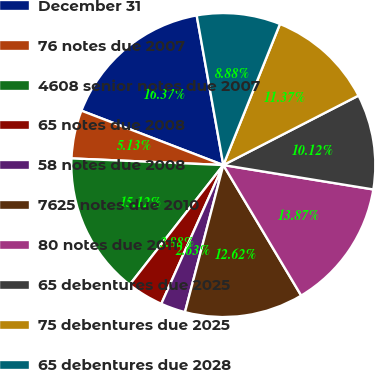Convert chart to OTSL. <chart><loc_0><loc_0><loc_500><loc_500><pie_chart><fcel>December 31<fcel>76 notes due 2007<fcel>4608 senior notes due 2007<fcel>65 notes due 2008<fcel>58 notes due 2008<fcel>7625 notes due 2010<fcel>80 notes due 2011<fcel>65 debentures due 2025<fcel>75 debentures due 2025<fcel>65 debentures due 2028<nl><fcel>16.37%<fcel>5.13%<fcel>15.12%<fcel>3.88%<fcel>2.63%<fcel>12.62%<fcel>13.87%<fcel>10.12%<fcel>11.37%<fcel>8.88%<nl></chart> 